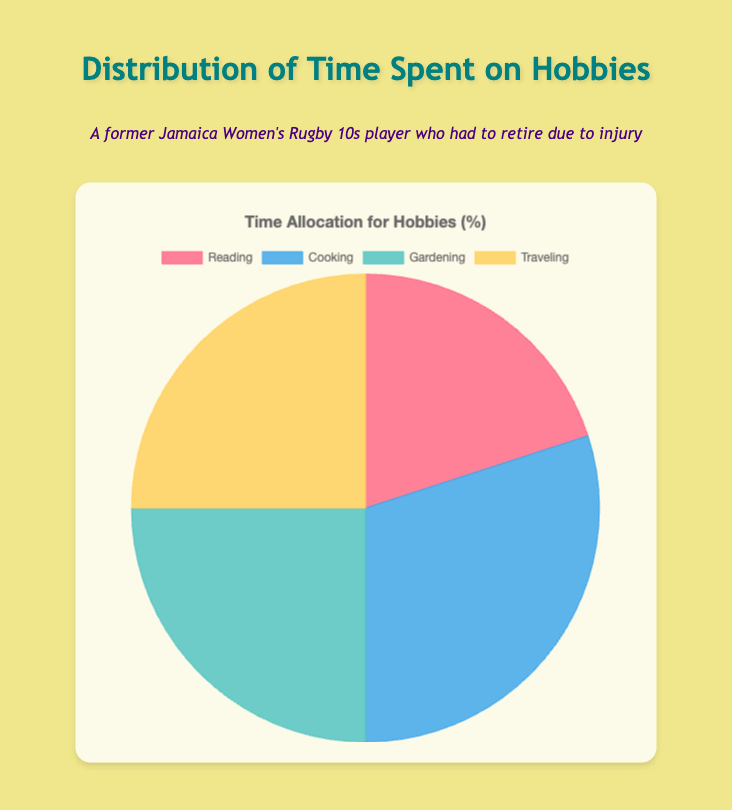What percentage of time is spent on Cooking vs. Reading? Cooking takes 30% of the pie and Reading takes 20%. Comparing these, Cooking is more.
Answer: Cooking: 30%, Reading: 20% Which two hobbies take up the largest proportion of the pie chart? The hobbies and their respective percentages are Cooking (30%), Gardening (25%), Traveling (25%), and Reading (20%). Cooking and the joint percentages of Gardening and Traveling are the highest.
Answer: Cooking and Gardening/Traveling How much more time is spent on Cooking compared to Reading? Cooking is 30% and Reading is 20%. Subtract Reading's percentage from Cooking's to find the difference. 30% - 20% = 10% more is spent on Cooking.
Answer: 10% If you add the time spent on Gardening and Traveling, what percentage do you get? Gardening is 25% and Traveling is 25%. Adding these together: 25% + 25% = 50%.
Answer: 50% Which hobby receives the least time allocation? From the chart, the percentages are: Reading 20%, Cooking 30%, Gardening 25%, Traveling 25%. Reading has the least percentage.
Answer: Reading What is the median percentage value of the time spent on the hobbies? Order the percentages: Reading (20%), Gardening (25%), Traveling (25%), Cooking (30%). The median value falls between Gardening and Traveling: (25% + 25%) / 2 = 25%.
Answer: 25% If time spent on Traveling were reduced by 10%, and this 10% was added to Reading, what would the new percentages be? Current Traveling is 25%, reducing by 10% makes it 15%. Reading is 20%, adding 10% makes it 30%. New percentages: Reading 30%, Traveling 15%.
Answer: Reading: 30%, Traveling: 15% Are there any hobbies that receive equal time allocation? From the chart, both Gardening and Traveling receive 25% each.
Answer: Gardening and Traveling What is the sum of time spent on Cooking and Reading? Cooking is 30% and Reading is 20%. Add these together: 30% + 20% = 50%.
Answer: 50% 